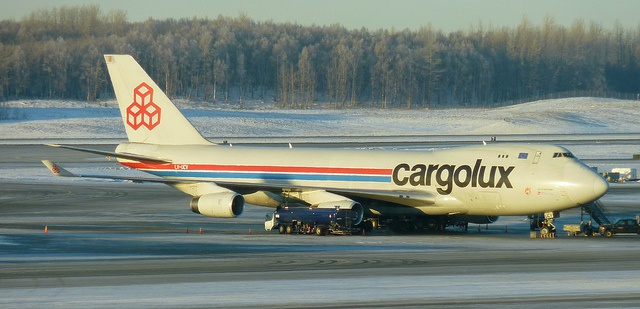Describe the objects in this image and their specific colors. I can see airplane in darkgray, beige, black, and gray tones and car in darkgray, black, teal, gray, and darkgreen tones in this image. 